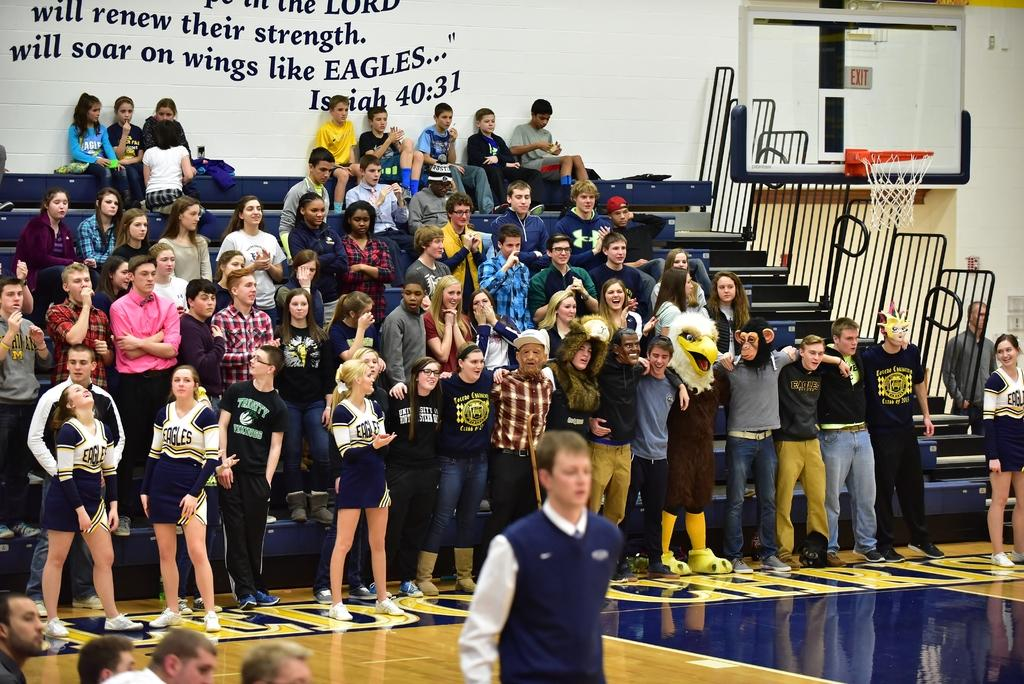<image>
Present a compact description of the photo's key features. A gym with students filling the bleachers under the verse Isaiah 40:31. 